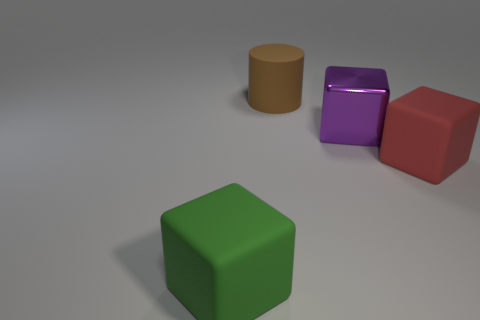Are there any other things that are made of the same material as the big cylinder?
Offer a very short reply. Yes. What is the shape of the purple metal object?
Your answer should be compact. Cube. What color is the cube that is both on the left side of the large red object and right of the big green matte thing?
Offer a very short reply. Purple. What is the big brown thing made of?
Keep it short and to the point. Rubber. The big thing that is right of the large shiny cube has what shape?
Offer a very short reply. Cube. What color is the matte block that is the same size as the green matte thing?
Provide a succinct answer. Red. Do the large cube in front of the large red cube and the large purple cube have the same material?
Ensure brevity in your answer.  No. There is a cube that is both in front of the large purple shiny block and right of the big matte cylinder; what size is it?
Keep it short and to the point. Large. What size is the rubber object to the left of the large cylinder?
Your answer should be very brief. Large. There is a large matte thing that is behind the matte cube behind the cube in front of the big red block; what is its shape?
Your response must be concise. Cylinder. 